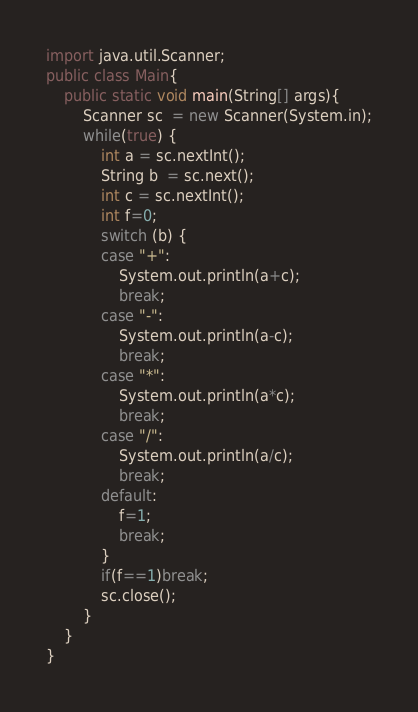Convert code to text. <code><loc_0><loc_0><loc_500><loc_500><_Java_>import java.util.Scanner;
public class Main{
    public static void main(String[] args){
        Scanner sc  = new Scanner(System.in);
        while(true) {
            int a = sc.nextInt();
            String b  = sc.next();
            int c = sc.nextInt();
            int f=0;
            switch (b) {
    		case "+":
    			System.out.println(a+c);
    			break;
    		case "-":
    			System.out.println(a-c);
    			break;
    		case "*":
    			System.out.println(a*c);
    			break;
    		case "/":
    			System.out.println(a/c);
    			break;
    		default:
    			f=1;
    			break;
            }
            if(f==1)break;
            sc.close();
        }
    }
}

</code> 